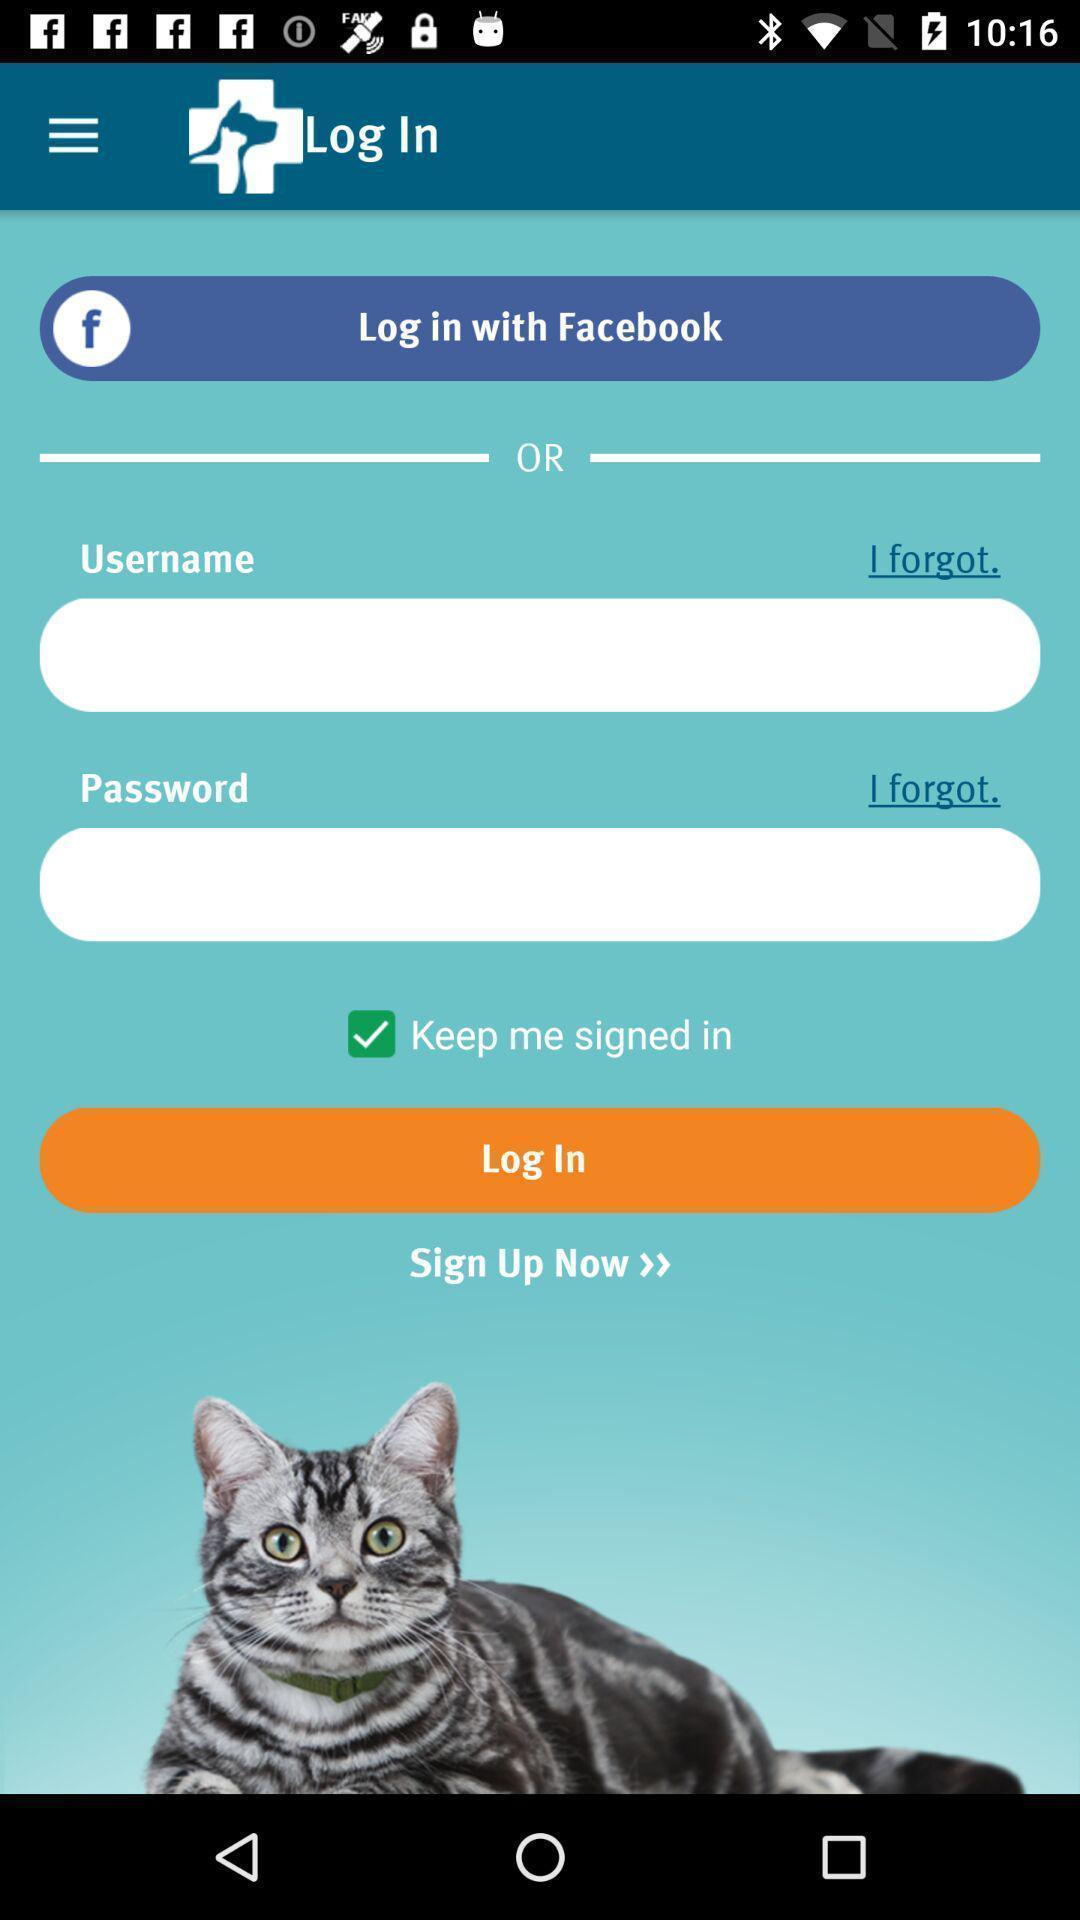Tell me what you see in this picture. Login page with social app displayed. 